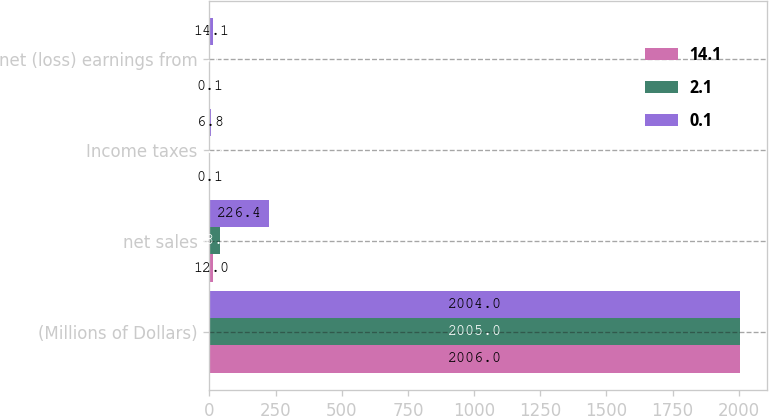<chart> <loc_0><loc_0><loc_500><loc_500><stacked_bar_chart><ecel><fcel>(Millions of Dollars)<fcel>net sales<fcel>Income taxes<fcel>net (loss) earnings from<nl><fcel>14.1<fcel>2006<fcel>12<fcel>0.1<fcel>0.1<nl><fcel>2.1<fcel>2005<fcel>38.7<fcel>0.9<fcel>2.1<nl><fcel>0.1<fcel>2004<fcel>226.4<fcel>6.8<fcel>14.1<nl></chart> 